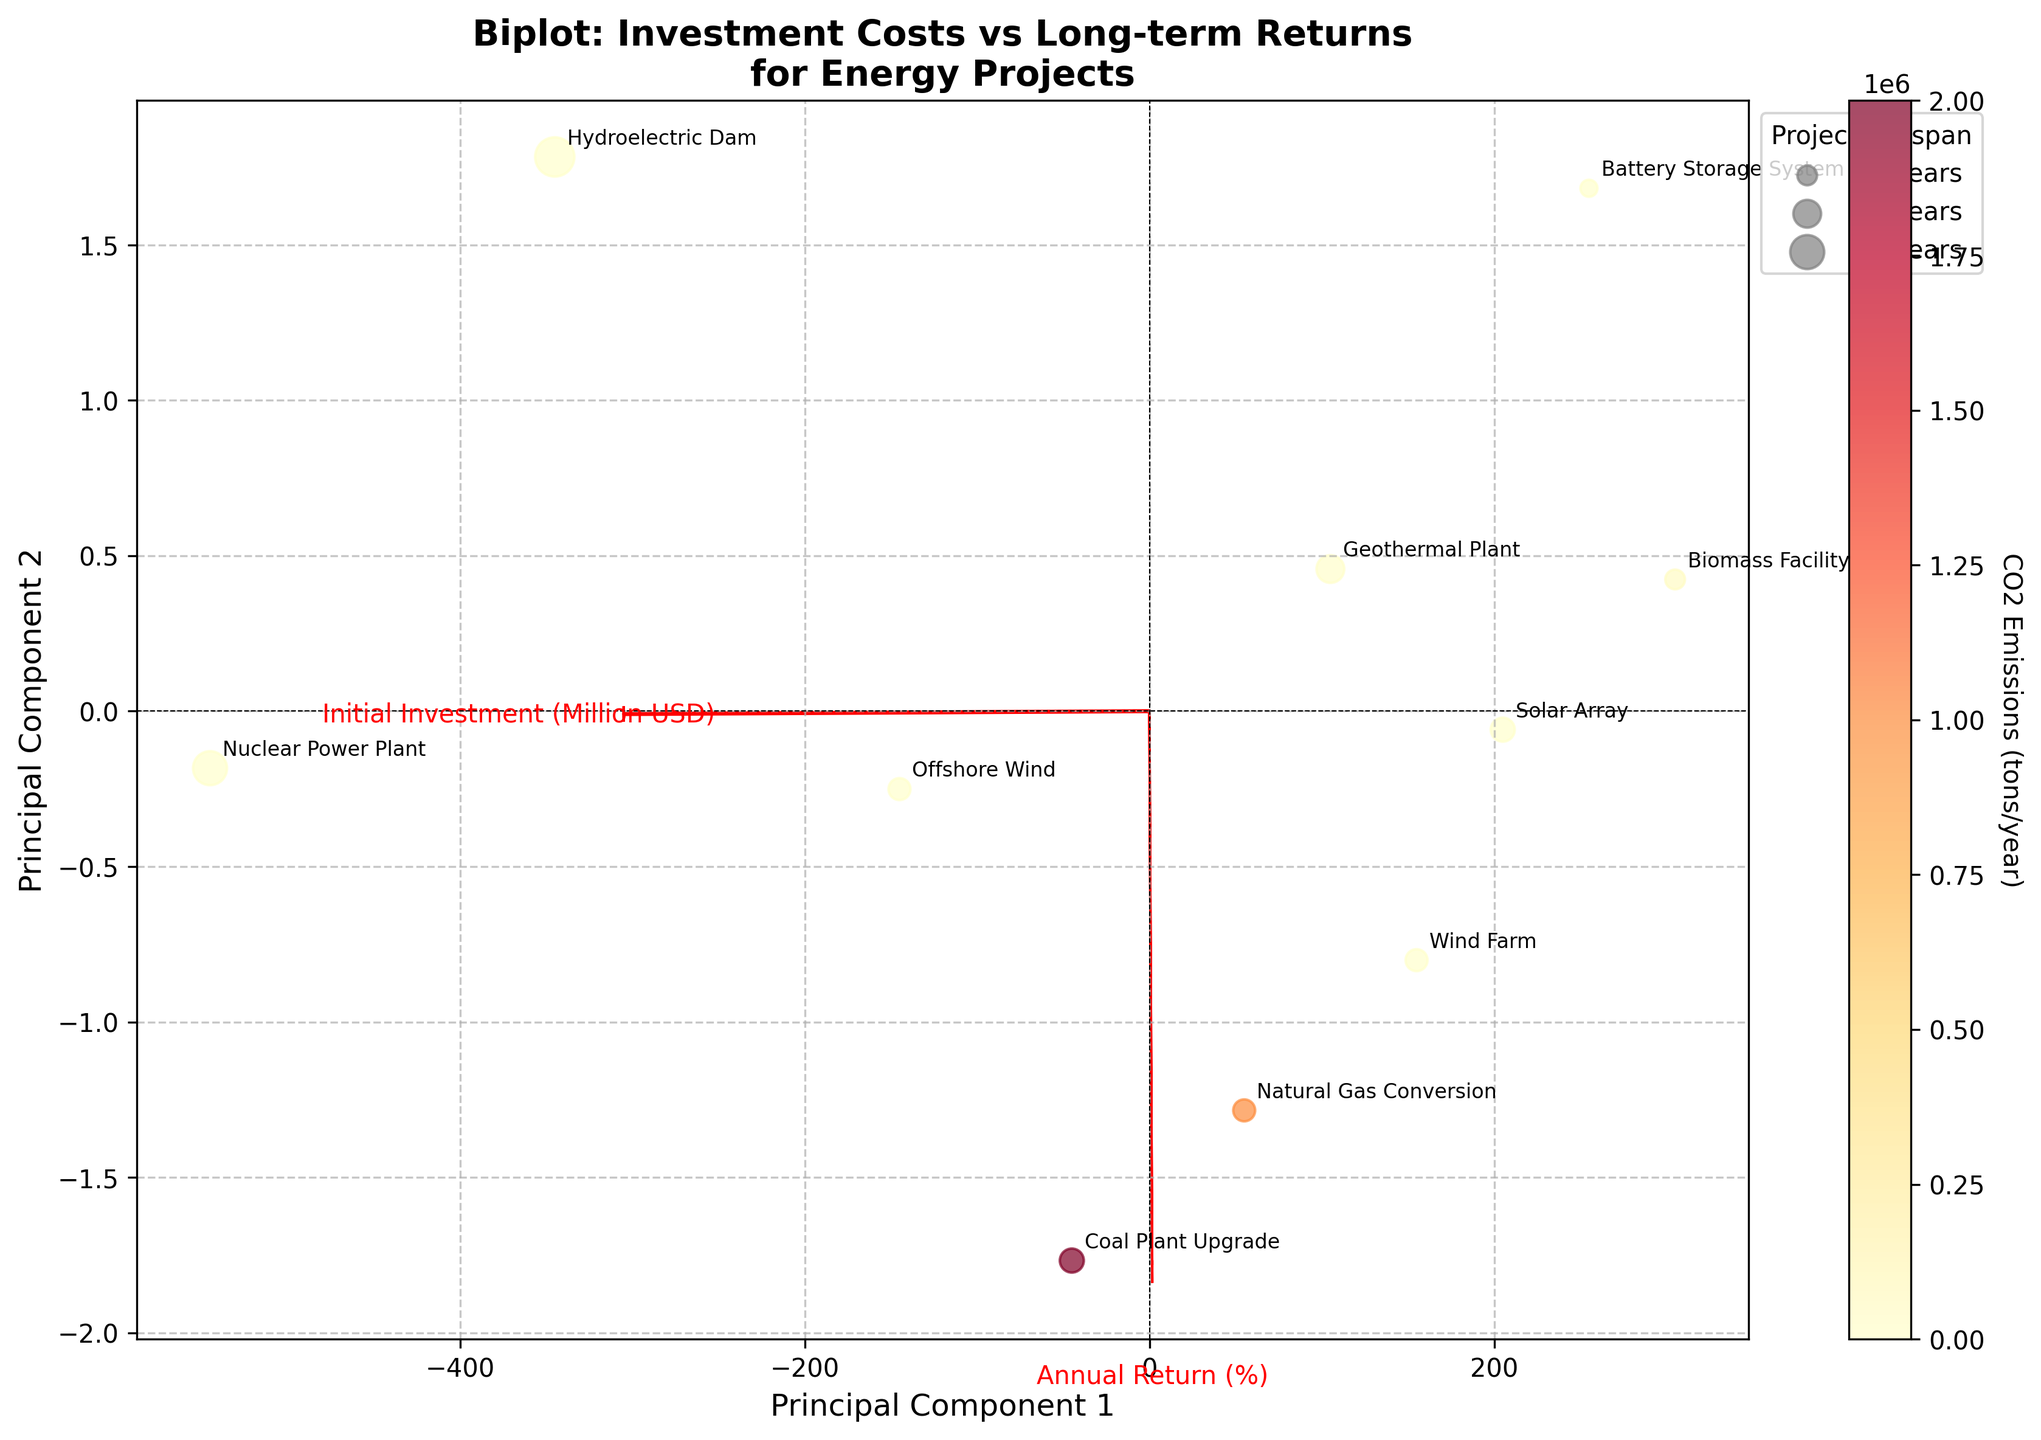Which project has the highest initial investment? The title of the biplot indicates that the projects are denoted by their scores on the first and second principal components. The project with the highest initial investment will have a label indicating it.
Answer: Nuclear Power Plant What does the color of the points represent? The color of the points is associated with a colorbar labeled 'CO2 Emissions (tons/year)', indicating that the color represents CO2 emissions.
Answer: CO2 Emissions Which project has the longest lifespan? The legend on the right shows bubble sizes correspond to project lifespans, with larger bubbles indicating longer lifespans. Looking at the size of the bubbles, the project with the largest bubble and its label is identified.
Answer: Hydroelectric Dam How many projects have zero CO2 emissions? The color of the points indicates CO2 emissions. Points with zero CO2 emissions will be of a different color compared to those with emissions. Identify and count these points by their color.
Answer: 6 Which project lies closest to the origin of the biplot? The origin of the biplot is where the axes intersect. The closest project will have its annotated point nearest to this intersection.
Answer: Geothermal Plant How do you interpret the loadings of 'Initial Investment' and 'Annual Return'? The red arrows indicate the direction and magnitude of loadings for 'Initial Investment' and 'Annual Return'. The direction of each arrow shows how much each principal component can be associated with an increase in these variables. The length of the arrows indicates the strength of this relationship.
Answer: Direction and magnitude of the biplot arrows Which has a better long-term return, wind farms or solar arrays? The biplot plots 'Initial Investment' vs 'Annual Return'. Comparing the y-axis positions of Wind Farm and Solar Array allows for the determination of which has a higher annual return.
Answer: Wind Farm Are there any high-emission projects with high lifespan? High CO2 emissions are indicated by color, and lifespan by bubble size. Identifying any large bubbles in the high CO2 emission colors answers this.
Answer: No What is the relationship between 'Initial Investment' and 'Annual Return' inferred from the biplot? Observing the direction and angle between 'Initial Investment' and 'Annual Return' arrows, if they are positively correlated, they will point in similar directions. Otherwise, they will diverge.
Answer: Generally positive correlation Which renewable energy projects require more initial investment than the coal plant upgrade? Identifying renewable projects involves excluding fossil fuel-based projects, then comparing their positions relative to the coal plant upgrade on the 'Initial Investment' axis.
Answer: Offshore Wind, Hydroelectric Dam 